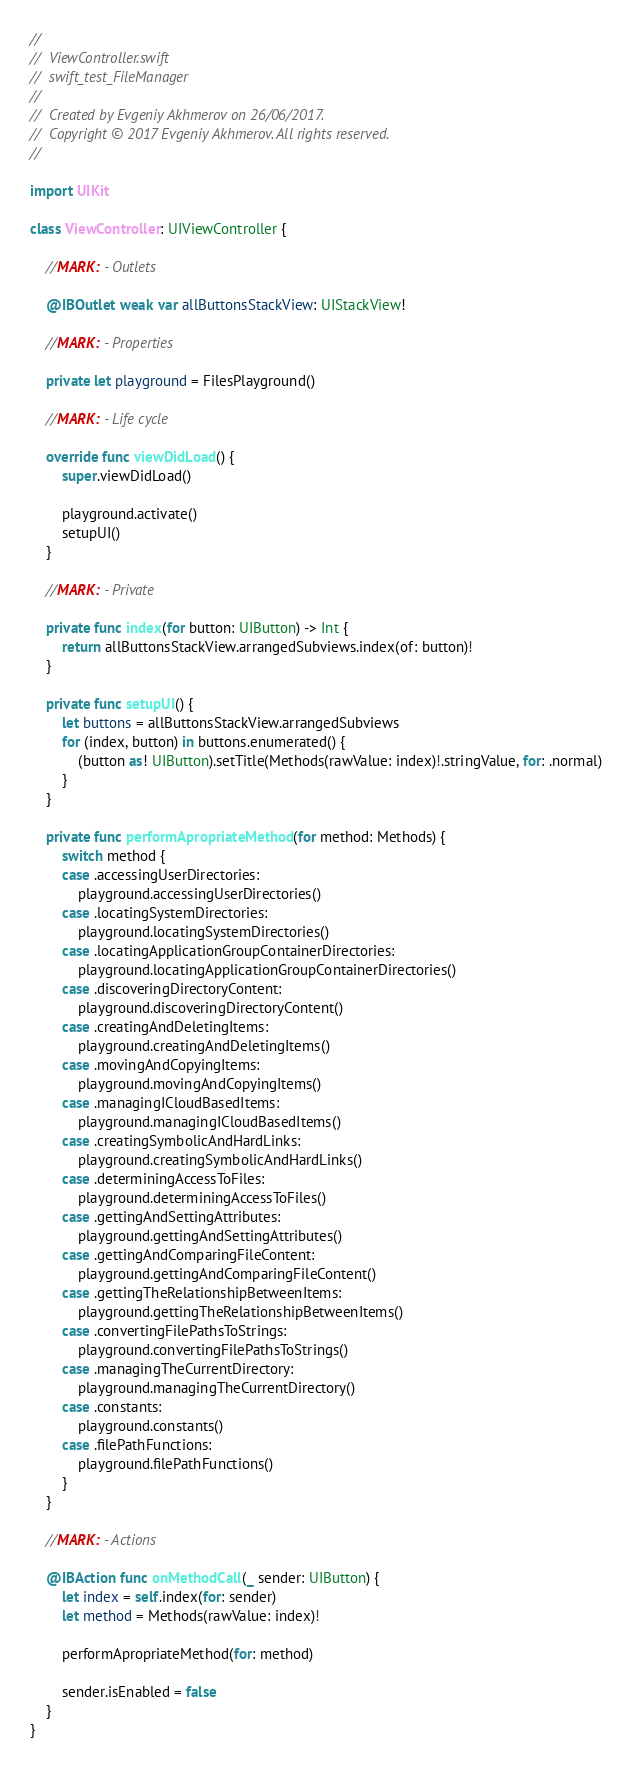<code> <loc_0><loc_0><loc_500><loc_500><_Swift_>//
//  ViewController.swift
//  swift_test_FileManager
//
//  Created by Evgeniy Akhmerov on 26/06/2017.
//  Copyright © 2017 Evgeniy Akhmerov. All rights reserved.
//

import UIKit

class ViewController: UIViewController {
    
    //MARK: - Outlets
    
    @IBOutlet weak var allButtonsStackView: UIStackView!
    
    //MARK: - Properties
    
    private let playground = FilesPlayground()
    
    //MARK: - Life cycle
    
    override func viewDidLoad() {
        super.viewDidLoad()
        
        playground.activate()
        setupUI()
    }
    
    //MARK: - Private
    
    private func index(for button: UIButton) -> Int {
        return allButtonsStackView.arrangedSubviews.index(of: button)!
    }
    
    private func setupUI() {
        let buttons = allButtonsStackView.arrangedSubviews
        for (index, button) in buttons.enumerated() {
            (button as! UIButton).setTitle(Methods(rawValue: index)!.stringValue, for: .normal)
        }
    }
    
    private func performApropriateMethod(for method: Methods) {
        switch method {
        case .accessingUserDirectories:
            playground.accessingUserDirectories()
        case .locatingSystemDirectories:
            playground.locatingSystemDirectories()
        case .locatingApplicationGroupContainerDirectories:
            playground.locatingApplicationGroupContainerDirectories()
        case .discoveringDirectoryContent:
            playground.discoveringDirectoryContent()
        case .creatingAndDeletingItems:
            playground.creatingAndDeletingItems()
        case .movingAndCopyingItems:
            playground.movingAndCopyingItems()
        case .managingICloudBasedItems:
            playground.managingICloudBasedItems()
        case .creatingSymbolicAndHardLinks:
            playground.creatingSymbolicAndHardLinks()
        case .determiningAccessToFiles:
            playground.determiningAccessToFiles()
        case .gettingAndSettingAttributes:
            playground.gettingAndSettingAttributes()
        case .gettingAndComparingFileContent:
            playground.gettingAndComparingFileContent()
        case .gettingTheRelationshipBetweenItems:
            playground.gettingTheRelationshipBetweenItems()
        case .convertingFilePathsToStrings:
            playground.convertingFilePathsToStrings()
        case .managingTheCurrentDirectory:
            playground.managingTheCurrentDirectory()
        case .constants:
            playground.constants()
        case .filePathFunctions:
            playground.filePathFunctions()
        }
    }
    
    //MARK: - Actions
    
    @IBAction func onMethodCall(_ sender: UIButton) {
        let index = self.index(for: sender)
        let method = Methods(rawValue: index)!
        
        performApropriateMethod(for: method)
        
        sender.isEnabled = false
    }
}
</code> 